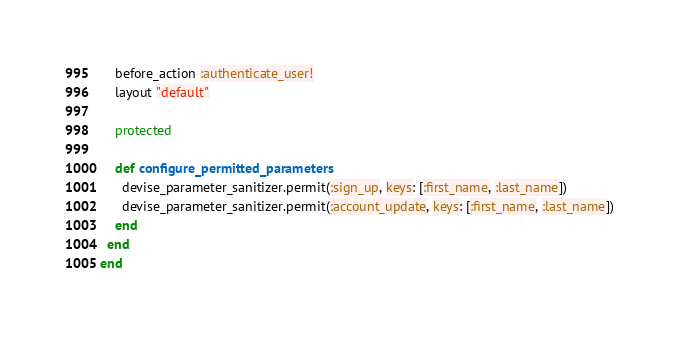Convert code to text. <code><loc_0><loc_0><loc_500><loc_500><_Ruby_>	before_action :authenticate_user!
	layout "default"

	protected

	def configure_permitted_parameters
	  devise_parameter_sanitizer.permit(:sign_up, keys: [:first_name, :last_name])
	  devise_parameter_sanitizer.permit(:account_update, keys: [:first_name, :last_name])
	end
  end
end
</code> 